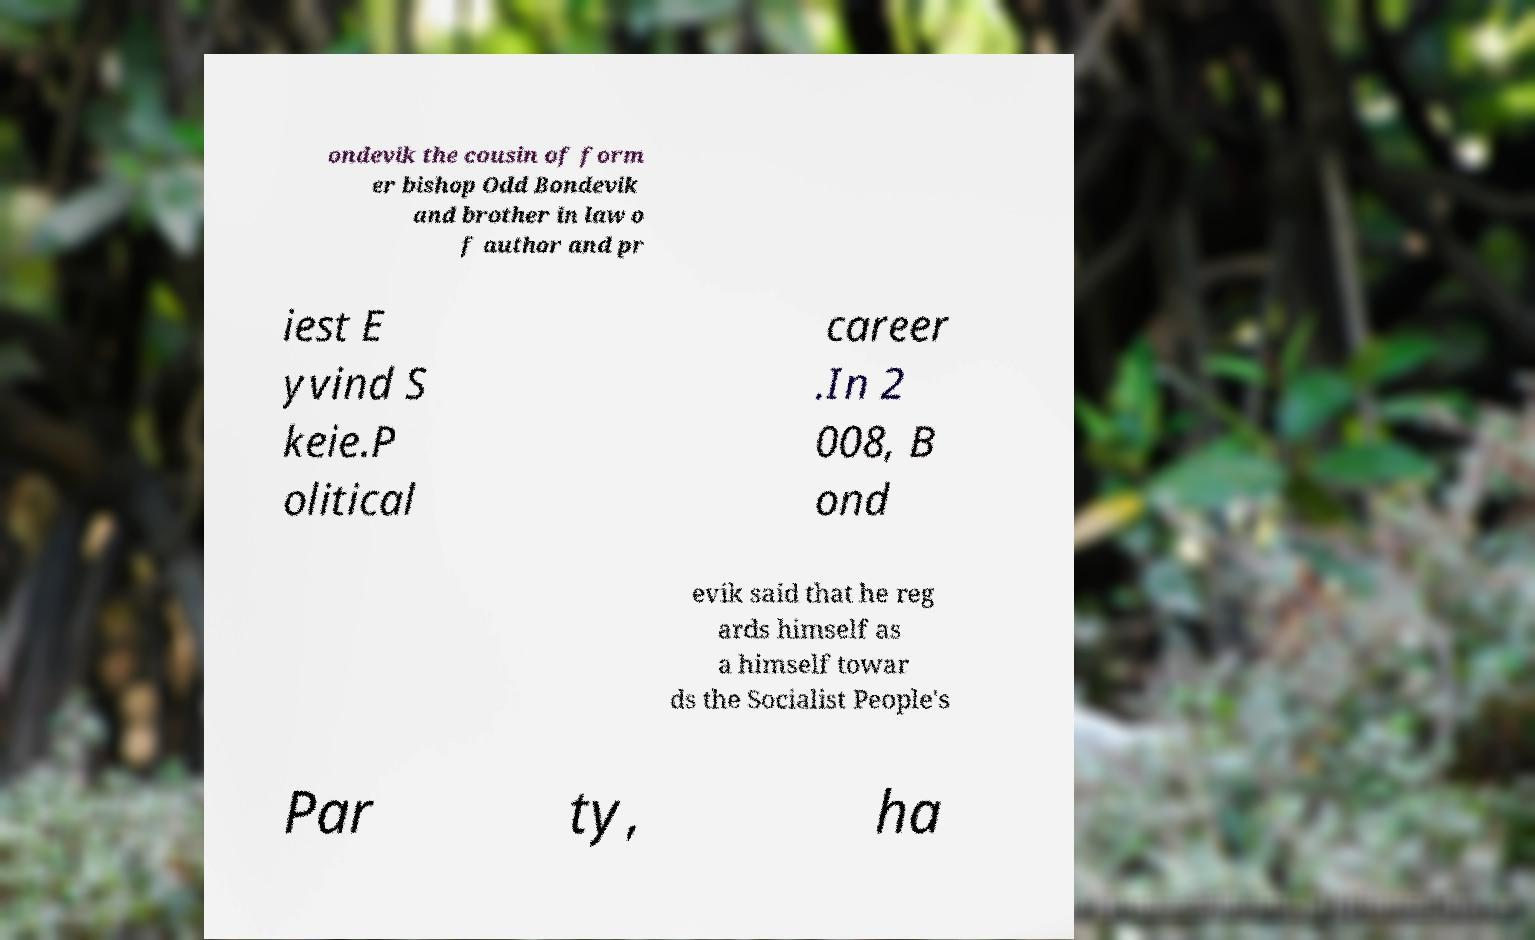I need the written content from this picture converted into text. Can you do that? ondevik the cousin of form er bishop Odd Bondevik and brother in law o f author and pr iest E yvind S keie.P olitical career .In 2 008, B ond evik said that he reg ards himself as a himself towar ds the Socialist People's Par ty, ha 